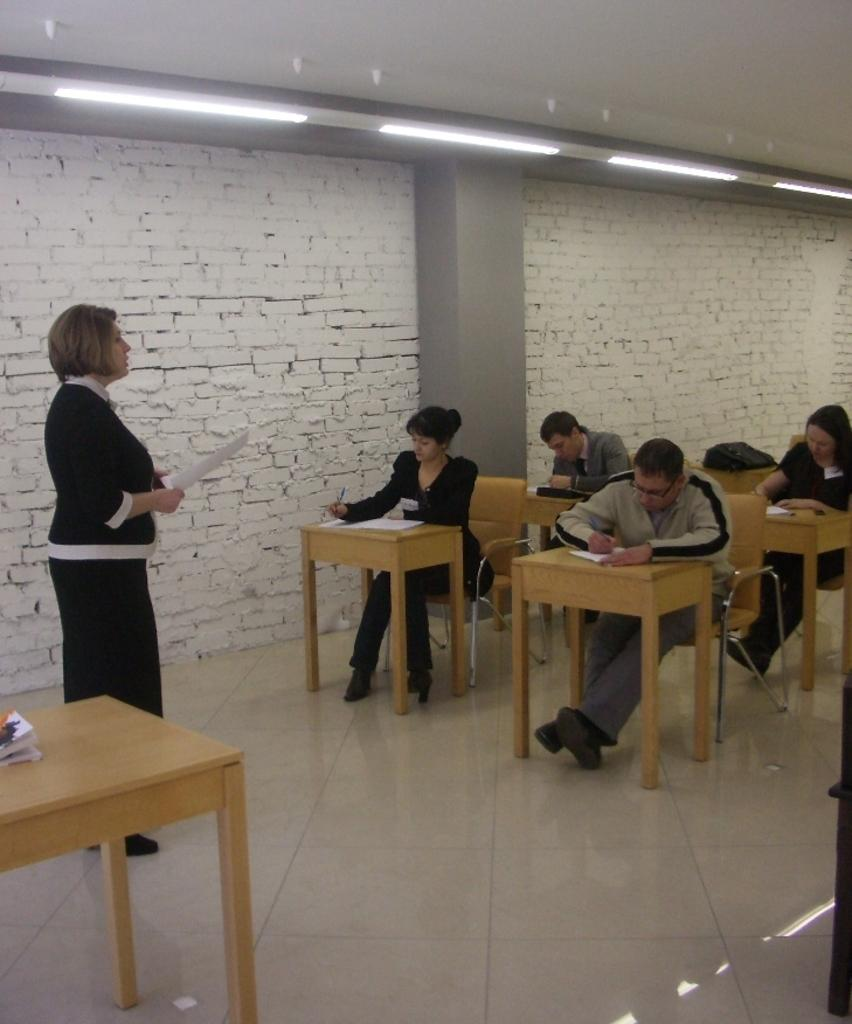What type of structure is visible in the image? There is a brick wall in the image. What are the people in the image doing? The people are sitting on chairs in the image. What furniture is present in the image? There are tables in the image. What items can be seen on the tables? Papers are present on the tables. What type of drink is being served in the image? There is no drink visible in the image. Are there any bears present in the image? No, there are no bears present in the image. 